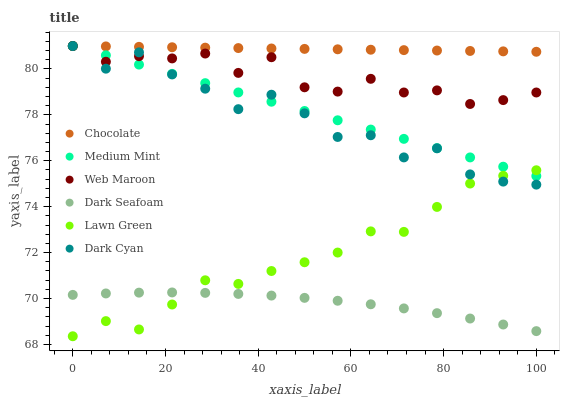Does Dark Seafoam have the minimum area under the curve?
Answer yes or no. Yes. Does Chocolate have the maximum area under the curve?
Answer yes or no. Yes. Does Lawn Green have the minimum area under the curve?
Answer yes or no. No. Does Lawn Green have the maximum area under the curve?
Answer yes or no. No. Is Chocolate the smoothest?
Answer yes or no. Yes. Is Dark Cyan the roughest?
Answer yes or no. Yes. Is Lawn Green the smoothest?
Answer yes or no. No. Is Lawn Green the roughest?
Answer yes or no. No. Does Lawn Green have the lowest value?
Answer yes or no. Yes. Does Web Maroon have the lowest value?
Answer yes or no. No. Does Dark Cyan have the highest value?
Answer yes or no. Yes. Does Lawn Green have the highest value?
Answer yes or no. No. Is Dark Seafoam less than Chocolate?
Answer yes or no. Yes. Is Medium Mint greater than Dark Seafoam?
Answer yes or no. Yes. Does Dark Cyan intersect Medium Mint?
Answer yes or no. Yes. Is Dark Cyan less than Medium Mint?
Answer yes or no. No. Is Dark Cyan greater than Medium Mint?
Answer yes or no. No. Does Dark Seafoam intersect Chocolate?
Answer yes or no. No. 